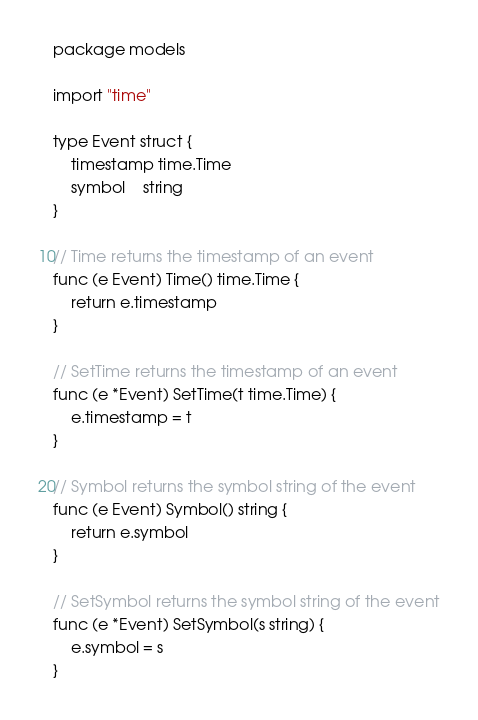Convert code to text. <code><loc_0><loc_0><loc_500><loc_500><_Go_>package models

import "time"

type Event struct {
	timestamp time.Time
	symbol    string
}

// Time returns the timestamp of an event
func (e Event) Time() time.Time {
	return e.timestamp
}

// SetTime returns the timestamp of an event
func (e *Event) SetTime(t time.Time) {
	e.timestamp = t
}

// Symbol returns the symbol string of the event
func (e Event) Symbol() string {
	return e.symbol
}

// SetSymbol returns the symbol string of the event
func (e *Event) SetSymbol(s string) {
	e.symbol = s
}
</code> 